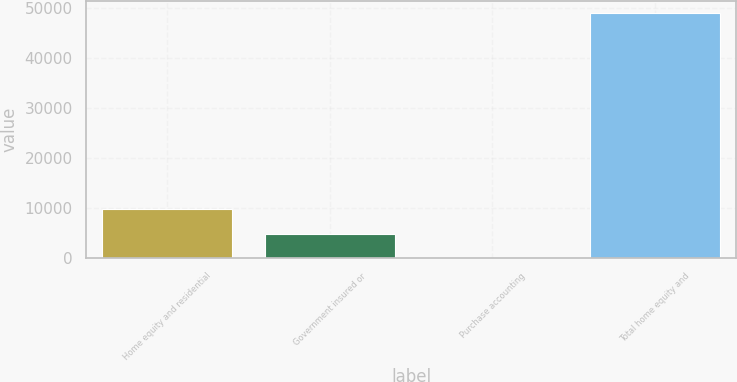Convert chart. <chart><loc_0><loc_0><loc_500><loc_500><bar_chart><fcel>Home equity and residential<fcel>Government insured or<fcel>Purchase accounting<fcel>Total home equity and<nl><fcel>9822.4<fcel>4914.7<fcel>7<fcel>49084<nl></chart> 